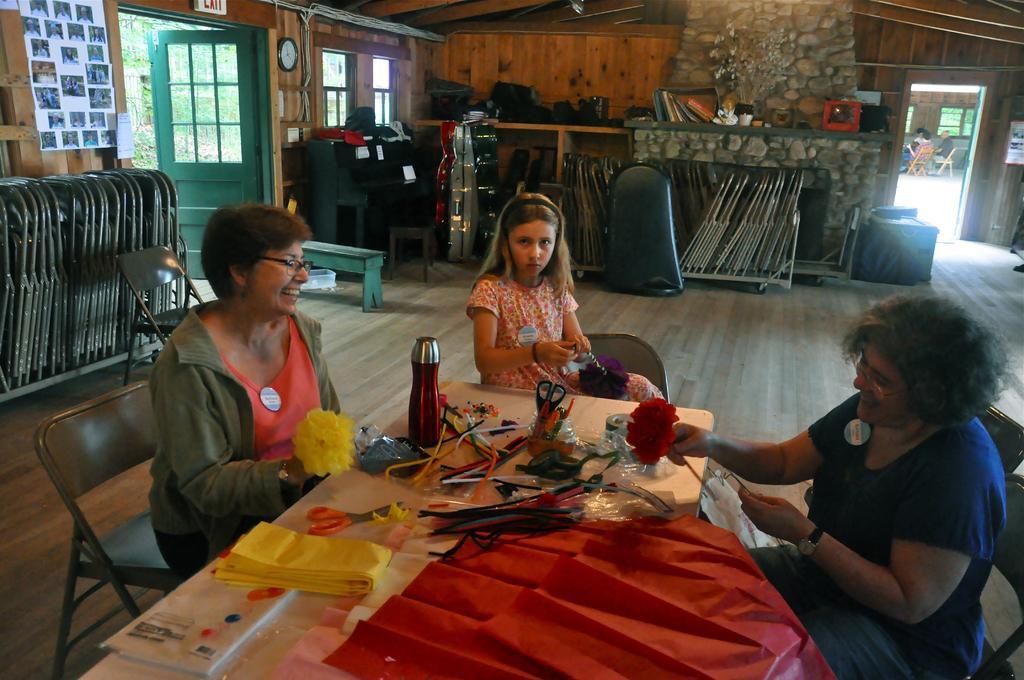In one or two sentences, can you explain what this image depicts? On the background we can see doors, exit board, clock, windows and photo frames over a wall. We can see a decorative wall with a stones. We can see chair. Here we can see few persons sitting on chairs and here also the same. And on the table we can see decorative paper flowers, scissors, book, bottle, chart papers. This is an empty chair. This is a bench. These are chairs arranged in a sequence manner. 